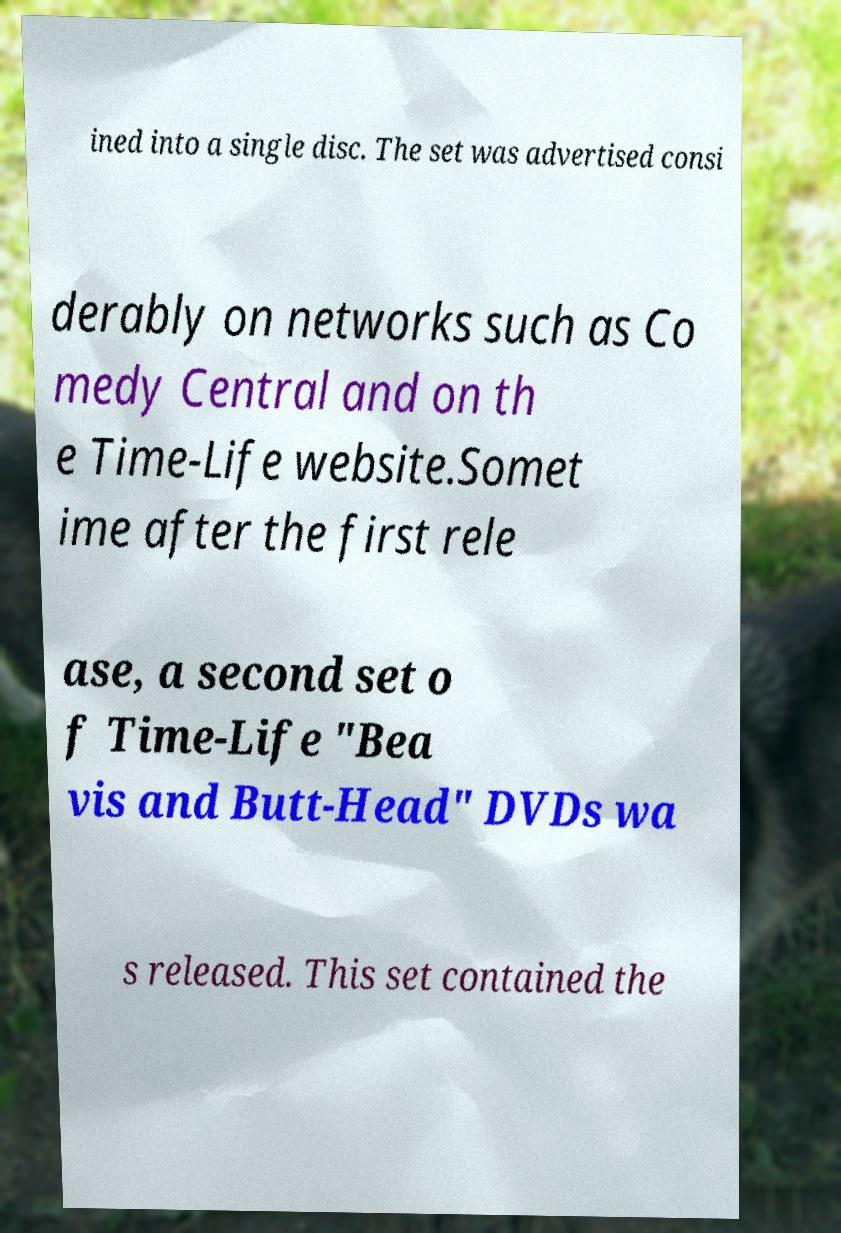Could you extract and type out the text from this image? ined into a single disc. The set was advertised consi derably on networks such as Co medy Central and on th e Time-Life website.Somet ime after the first rele ase, a second set o f Time-Life "Bea vis and Butt-Head" DVDs wa s released. This set contained the 